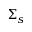Convert formula to latex. <formula><loc_0><loc_0><loc_500><loc_500>\Sigma _ { s }</formula> 